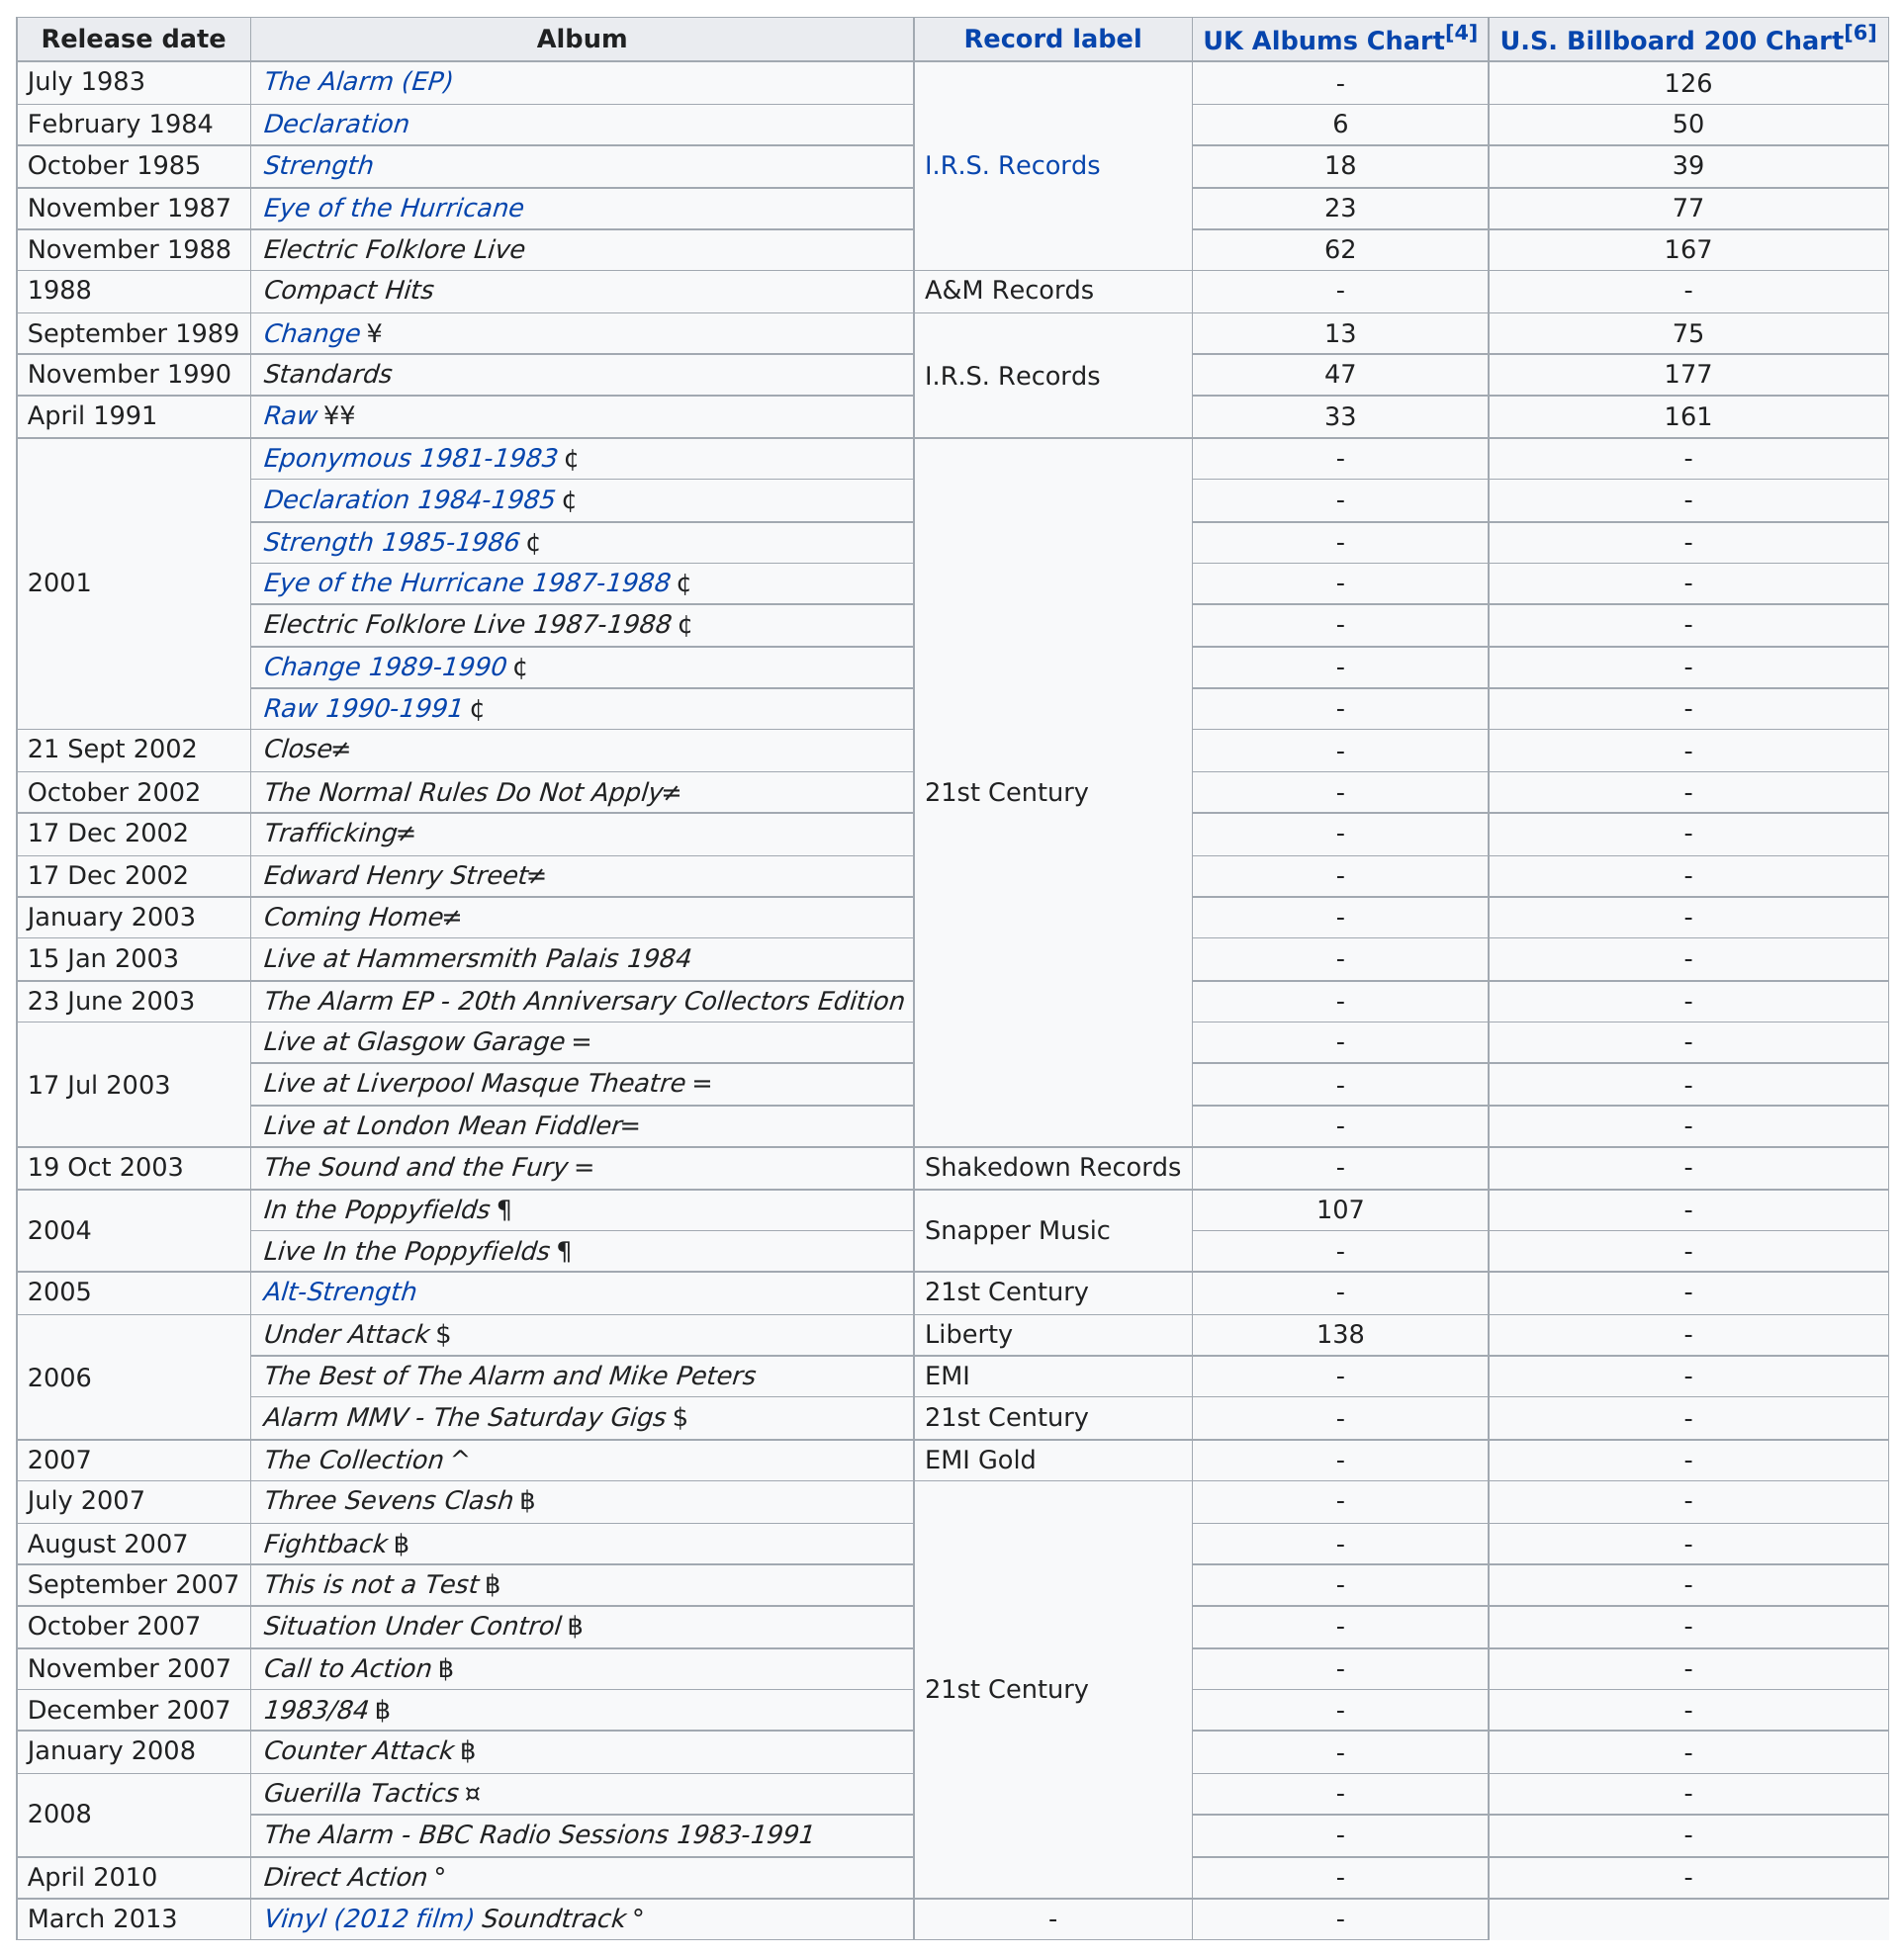Highlight a few significant elements in this photo. The album that was released after 'Raw' is 'Eponymous 1981-1983,' which contains the tracks 'The Storm' and 'The Electricity.' The Alarm (EP) is the name of the album that was the first to be released. In 2001, a total of 7 albums were released. The Alarm (EP) is the recorded album that is listed before February 1984. The first album released was "The Alarm (EP).. 